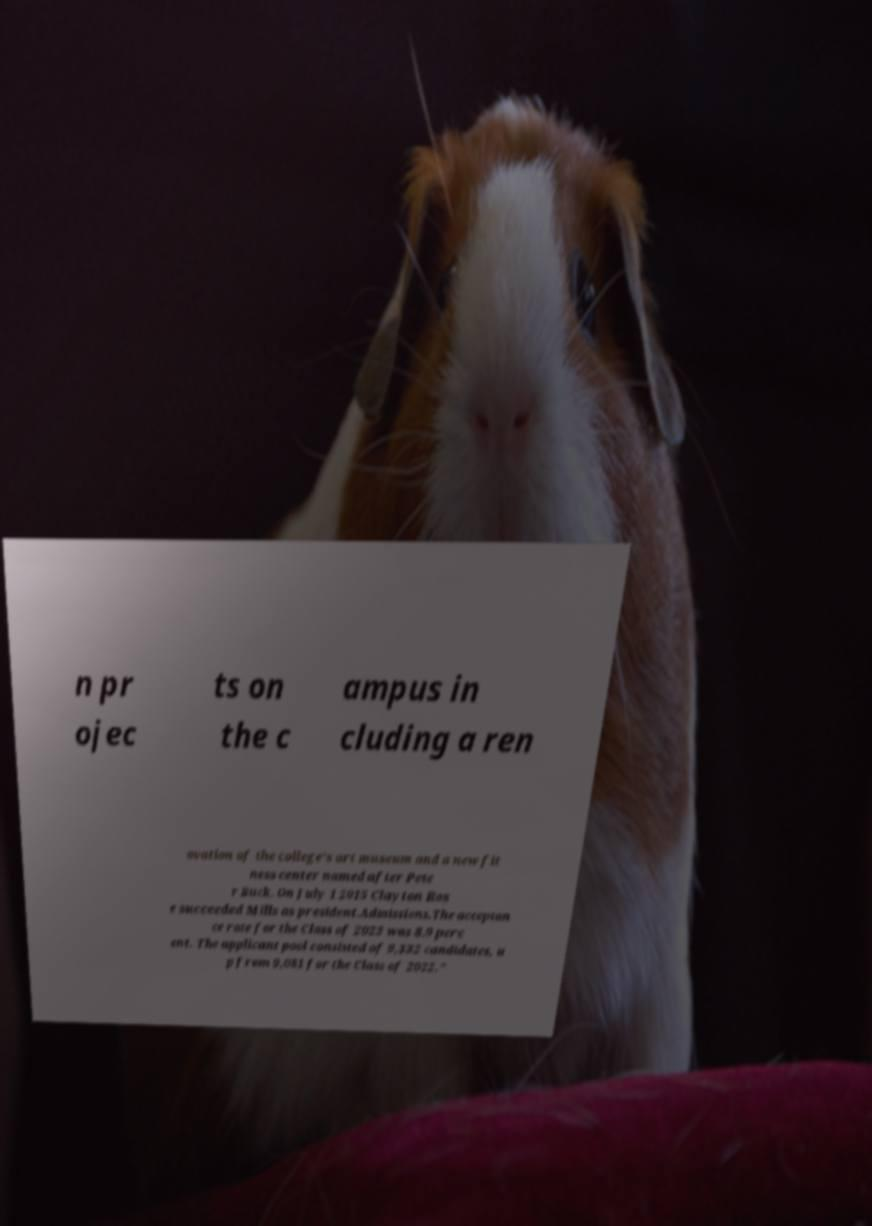Please identify and transcribe the text found in this image. n pr ojec ts on the c ampus in cluding a ren ovation of the college's art museum and a new fit ness center named after Pete r Buck. On July 1 2015 Clayton Ros e succeeded Mills as president.Admissions.The acceptan ce rate for the Class of 2023 was 8.9 perc ent. The applicant pool consisted of 9,332 candidates, u p from 9,081 for the Class of 2022." 